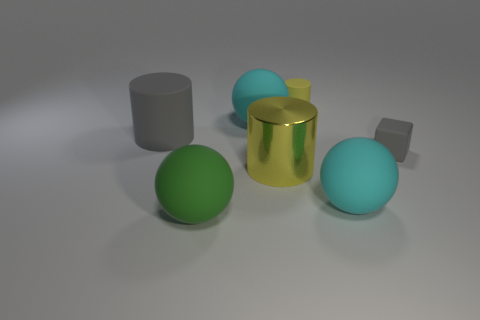Add 1 cyan metal blocks. How many objects exist? 8 Subtract all blocks. How many objects are left? 6 Add 2 tiny matte things. How many tiny matte things exist? 4 Subtract 0 yellow blocks. How many objects are left? 7 Subtract all cyan rubber things. Subtract all cyan objects. How many objects are left? 3 Add 3 big shiny cylinders. How many big shiny cylinders are left? 4 